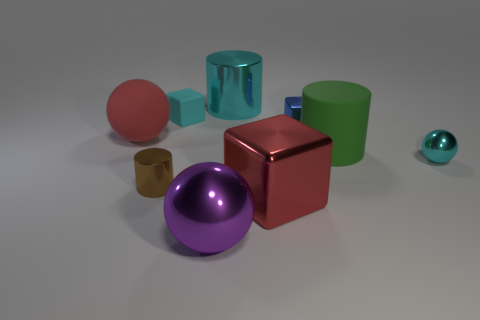There is a cyan thing that is right of the large red object that is to the right of the large purple metal object; what shape is it?
Offer a terse response. Sphere. What number of things are behind the large shiny block?
Your response must be concise. 7. Do the large cyan cylinder and the large cylinder right of the large cyan cylinder have the same material?
Make the answer very short. No. Is there a rubber ball that has the same size as the blue metallic thing?
Make the answer very short. No. Are there an equal number of green matte cylinders in front of the matte cylinder and large red things?
Offer a terse response. No. How big is the red metal cube?
Offer a very short reply. Large. There is a cyan object on the right side of the big cyan object; how many big blocks are behind it?
Your response must be concise. 0. The small thing that is on the right side of the red shiny block and in front of the big red sphere has what shape?
Provide a succinct answer. Sphere. How many other cylinders have the same color as the matte cylinder?
Provide a short and direct response. 0. Is there a large purple metal sphere behind the large metallic object that is behind the shiny cylinder that is to the left of the cyan rubber thing?
Provide a succinct answer. No. 